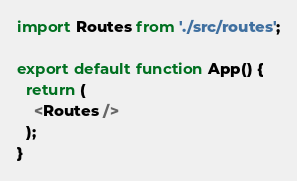<code> <loc_0><loc_0><loc_500><loc_500><_JavaScript_>import Routes from './src/routes';

export default function App() {
  return (
    <Routes />
  );
}


</code> 